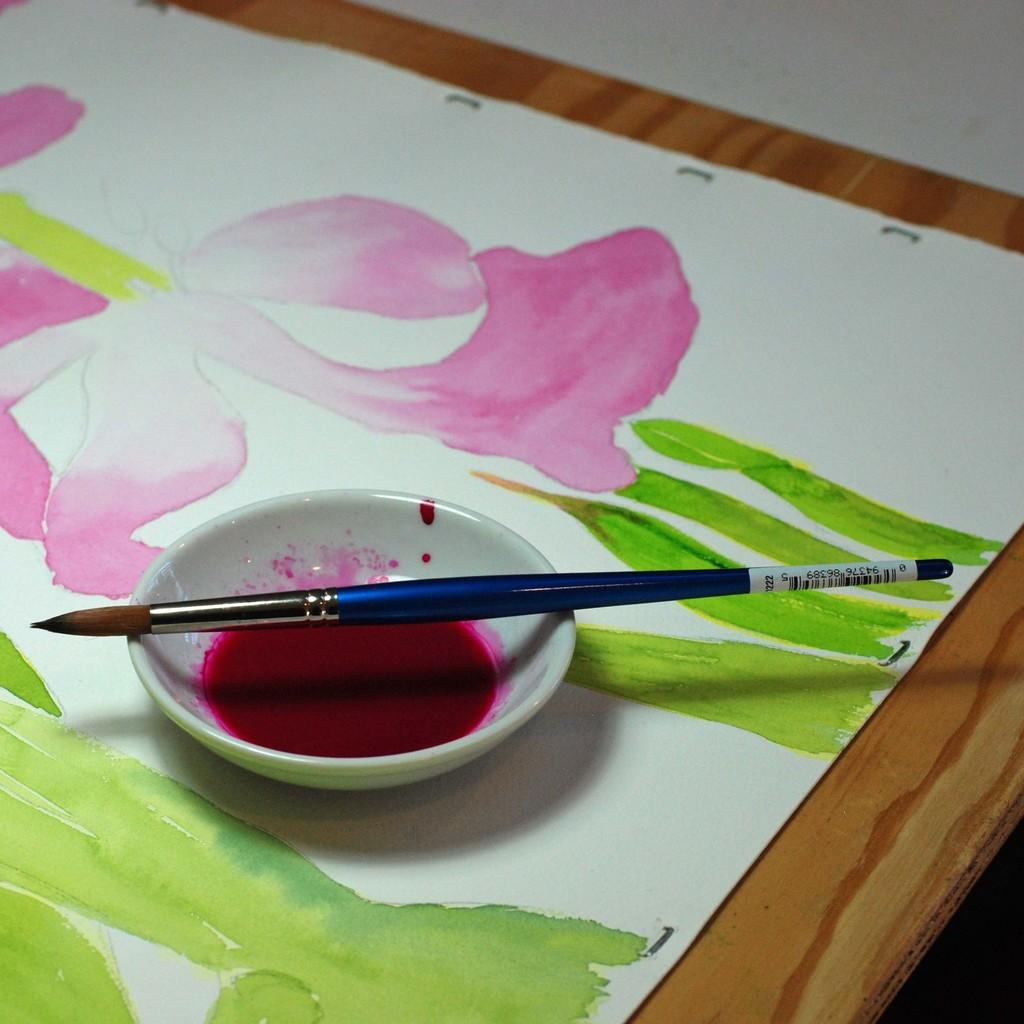What is the main object on the table in the image? There is a painting board on the table in the image. What else can be seen on the table? There is a bowl on the table. What might be used for applying color in the image? There is a brush in the image. What is the purpose of the color in the bowl? The color in the bowl is likely for use in painting. How does the artist express their anger through the painting in the image? There is no indication of anger or any emotional expression in the image; it simply shows a painting board, bowl, brush, and color. 